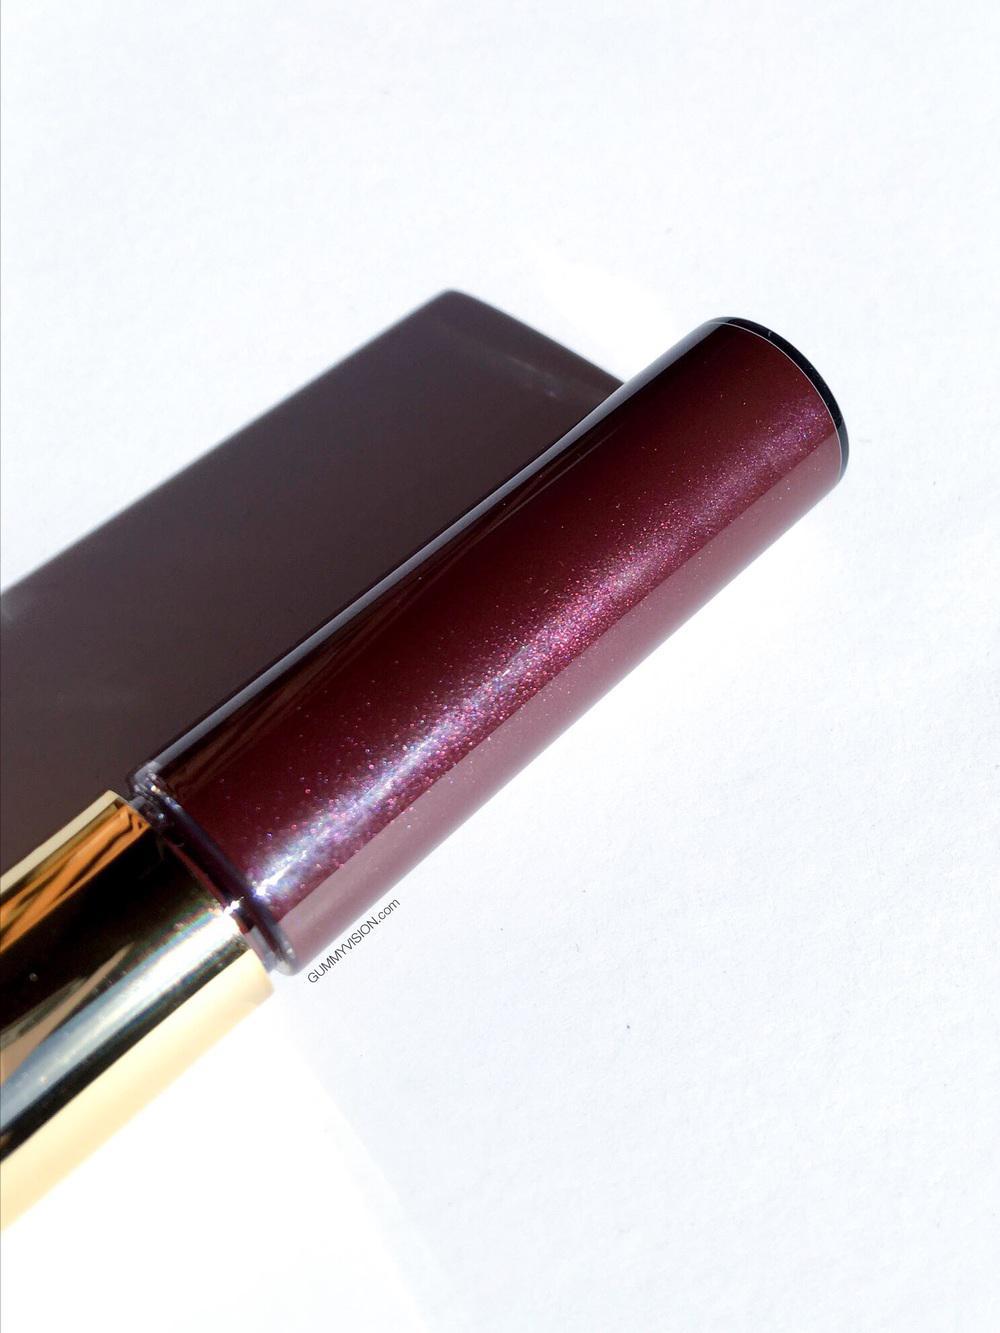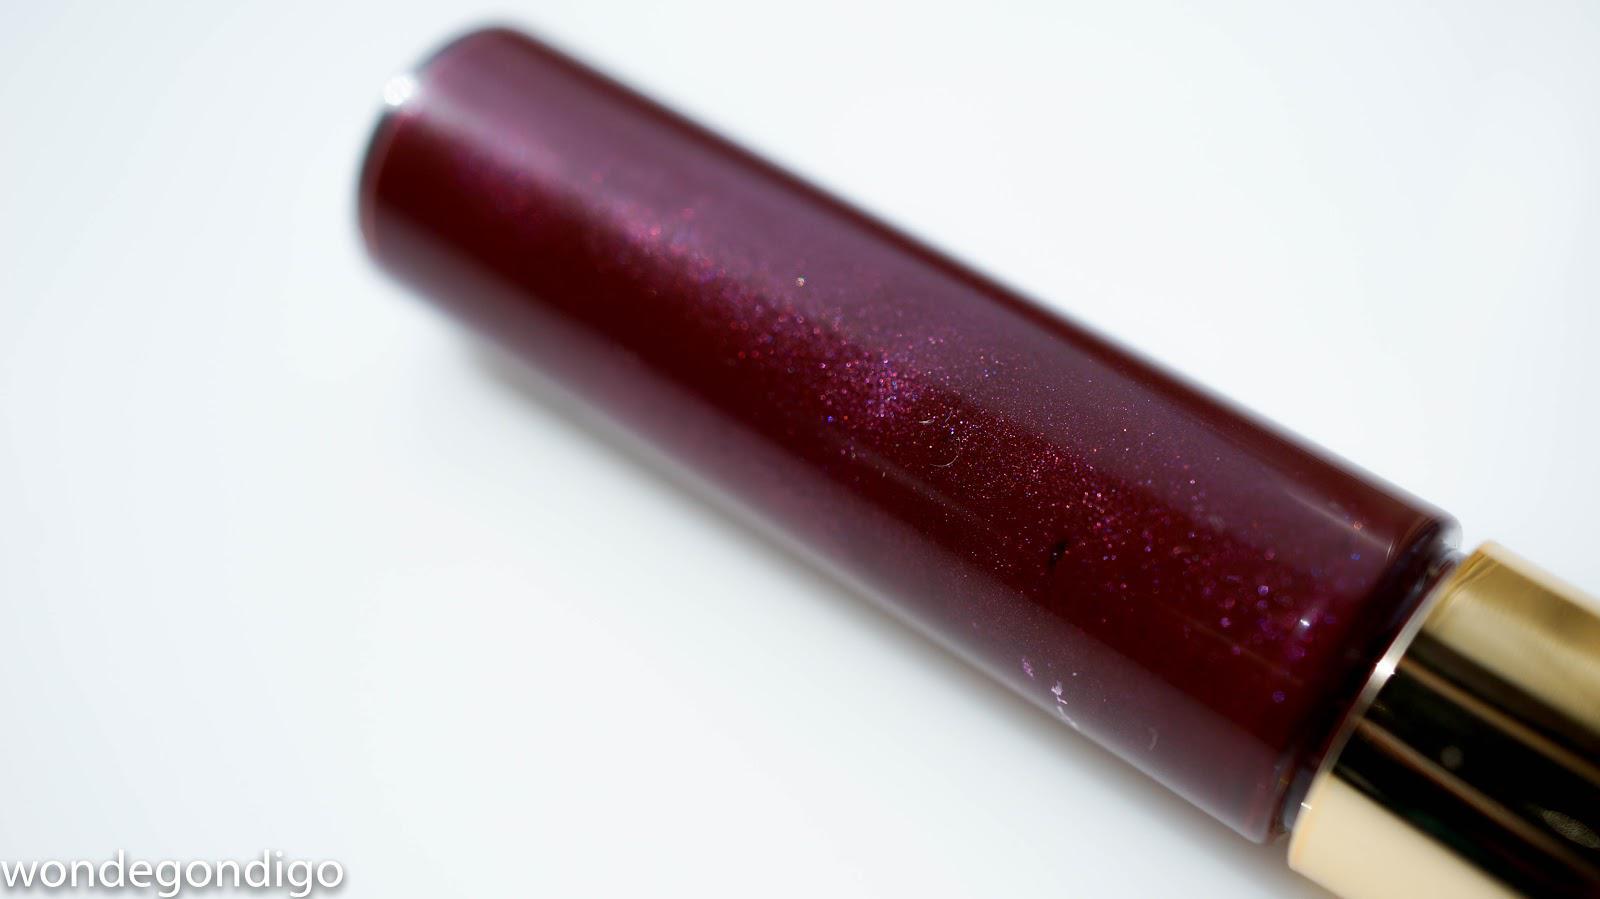The first image is the image on the left, the second image is the image on the right. Considering the images on both sides, is "All the items are capped." valid? Answer yes or no. Yes. The first image is the image on the left, the second image is the image on the right. For the images displayed, is the sentence "All lip makeups shown come in cylindrical bottles with clear glass that shows the reddish-purple color of the lip tint." factually correct? Answer yes or no. Yes. 